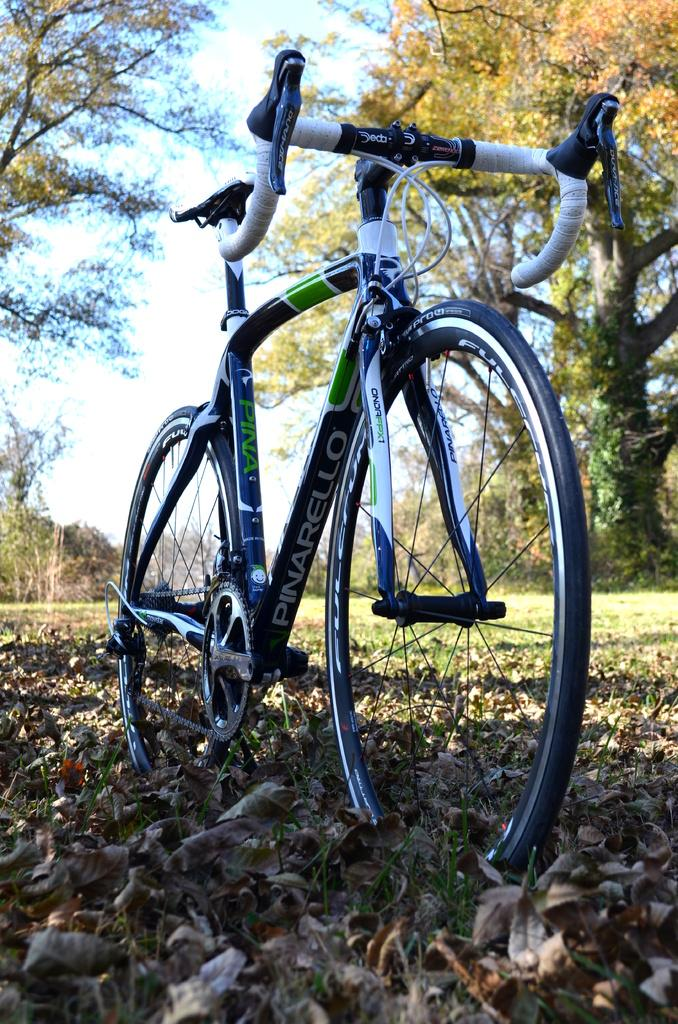What is the main object in the foreground of the image? There is a bicycle in the foreground of the image. What is the surface beneath the bicycle? The bicycle is on a dry grass floor. What can be seen in the background of the image? There are trees and grassland in the background of the image. What part of the natural environment is visible in the background? The sky is visible in the background of the image. Where is the rail for the swing located in the image? There is no swing or rail present in the image. What type of exchange is taking place between the trees in the image? There is no exchange taking place between the trees in the image; they are simply standing in the background. 